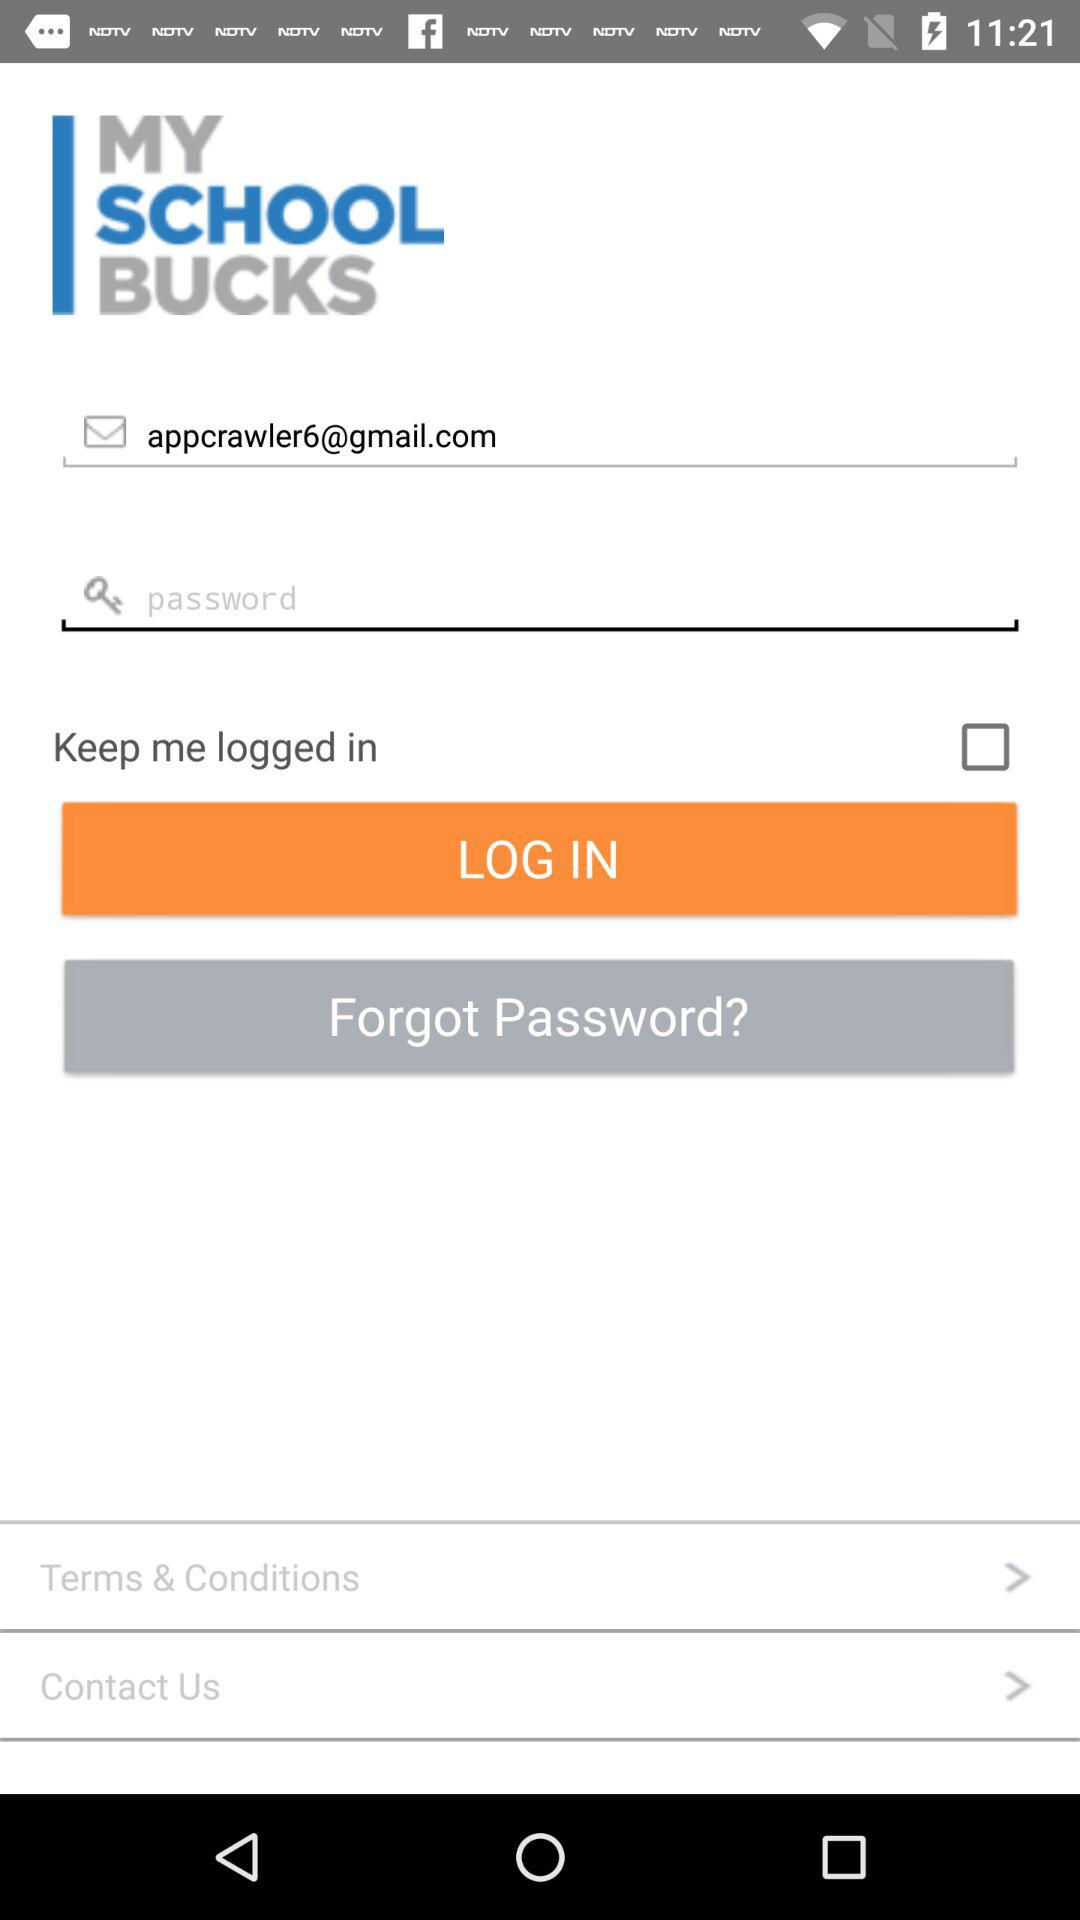What's the Google mail address? The mail address is appcrawler6@gmail.com. 